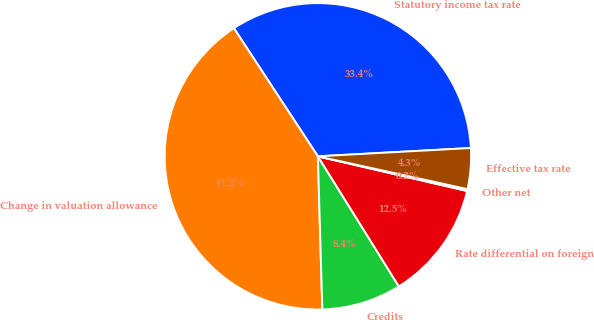<chart> <loc_0><loc_0><loc_500><loc_500><pie_chart><fcel>Statutory income tax rate<fcel>Change in valuation allowance<fcel>Credits<fcel>Rate differential on foreign<fcel>Other net<fcel>Effective tax rate<nl><fcel>33.37%<fcel>41.22%<fcel>8.4%<fcel>12.5%<fcel>0.2%<fcel>4.3%<nl></chart> 